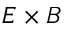<formula> <loc_0><loc_0><loc_500><loc_500>E \times B</formula> 